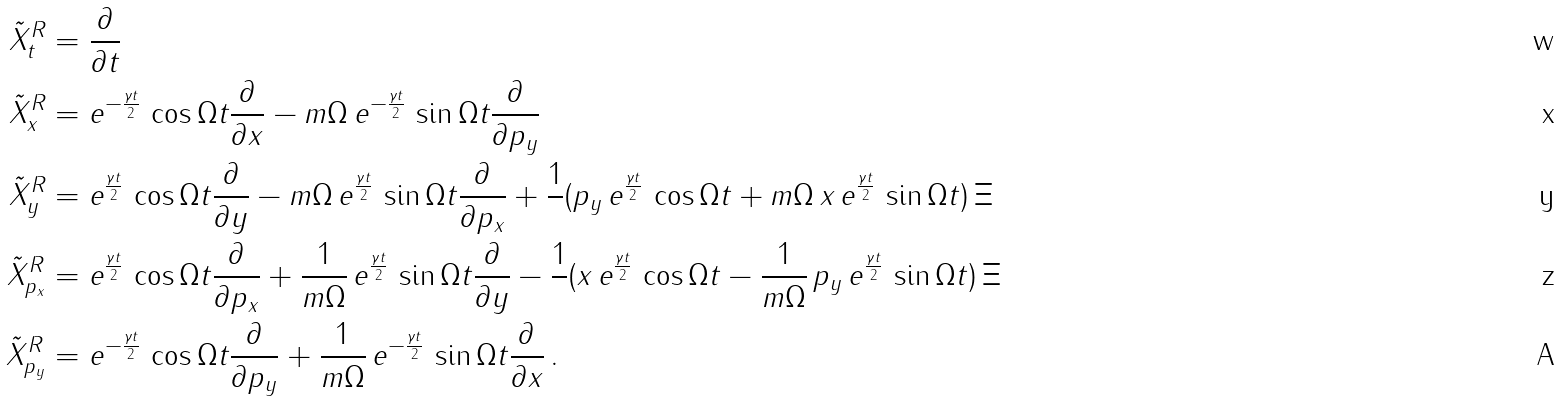Convert formula to latex. <formula><loc_0><loc_0><loc_500><loc_500>\tilde { X } _ { t } ^ { R } & = \frac { \partial } { \partial t } \\ \tilde { X } _ { x } ^ { R } & = e ^ { - \frac { \gamma t } { 2 } } \, \cos \Omega t \frac { \partial } { \partial x } - m \Omega \, e ^ { - \frac { \gamma t } { 2 } } \, \sin \Omega t \frac { \partial } { \partial p _ { y } } \\ \tilde { X } _ { y } ^ { R } & = e ^ { \frac { \gamma t } { 2 } } \, \cos \Omega t \frac { \partial } { \partial y } - m \Omega \, e ^ { \frac { \gamma t } { 2 } } \, \sin \Omega t \frac { \partial } { \partial p _ { x } } + \frac { 1 } { } ( p _ { y } \, e ^ { \frac { \gamma t } { 2 } } \, \cos \Omega t + m \Omega \, x \, e ^ { \frac { \gamma t } { 2 } } \, \sin \Omega t ) \, \Xi \\ \tilde { X } _ { p _ { x } } ^ { R } & = e ^ { \frac { \gamma t } { 2 } } \, \cos \Omega t \frac { \partial } { \partial p _ { x } } + \frac { 1 } { m \Omega } \, e ^ { \frac { \gamma t } { 2 } } \, \sin \Omega t \frac { \partial } { \partial y } - \frac { 1 } { } ( x \, e ^ { \frac { \gamma t } { 2 } } \, \cos \Omega t - \frac { 1 } { m \Omega } \, p _ { y } \, e ^ { \frac { \gamma t } { 2 } } \, \sin \Omega t ) \, \Xi \\ \tilde { X } _ { p _ { y } } ^ { R } & = e ^ { - \frac { \gamma t } { 2 } } \, \cos \Omega t \frac { \partial } { \partial p _ { y } } + \frac { 1 } { m \Omega } \, e ^ { - \frac { \gamma t } { 2 } } \, \sin \Omega t \frac { \partial } { \partial x } \, .</formula> 